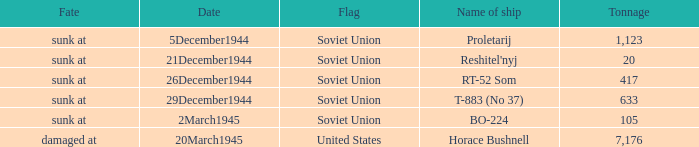What is the average tonnage of the ship named proletarij? 1123.0. 